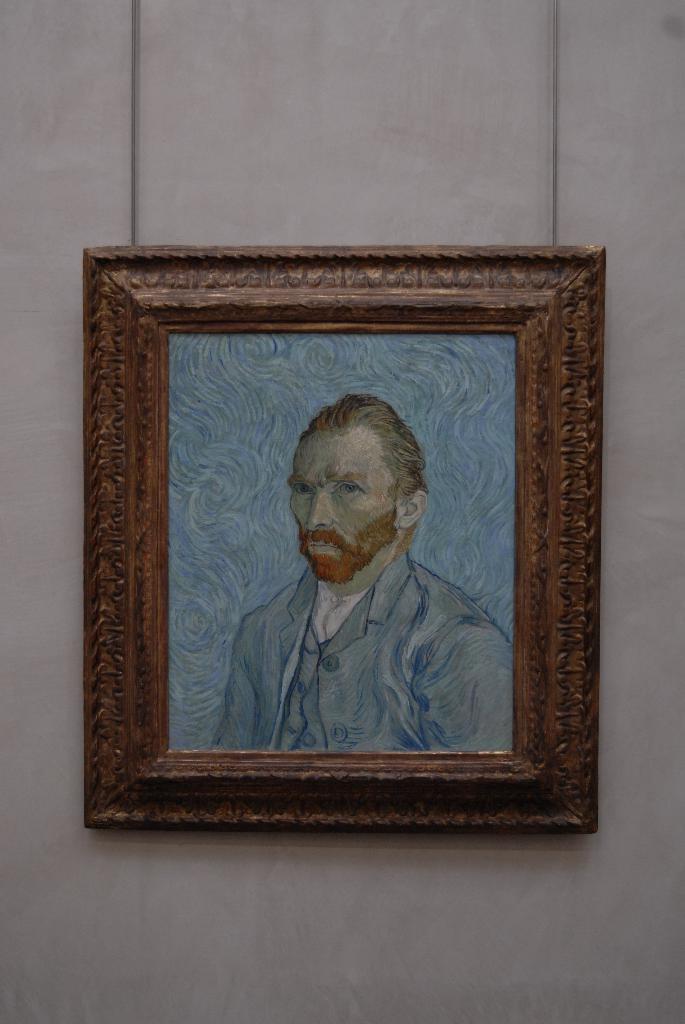What is located on the wall in the center of the image? There is a frame on the wall in the center of the image. What can be seen inside the frame? Unfortunately, the image does not provide enough detail to determine what is inside the frame. What is depicted on the board in the image? There is a sketch of a person on the board. How many dust particles can be seen on the sketch of the person? There is no mention of dust particles in the image, so it is impossible to determine their quantity. 